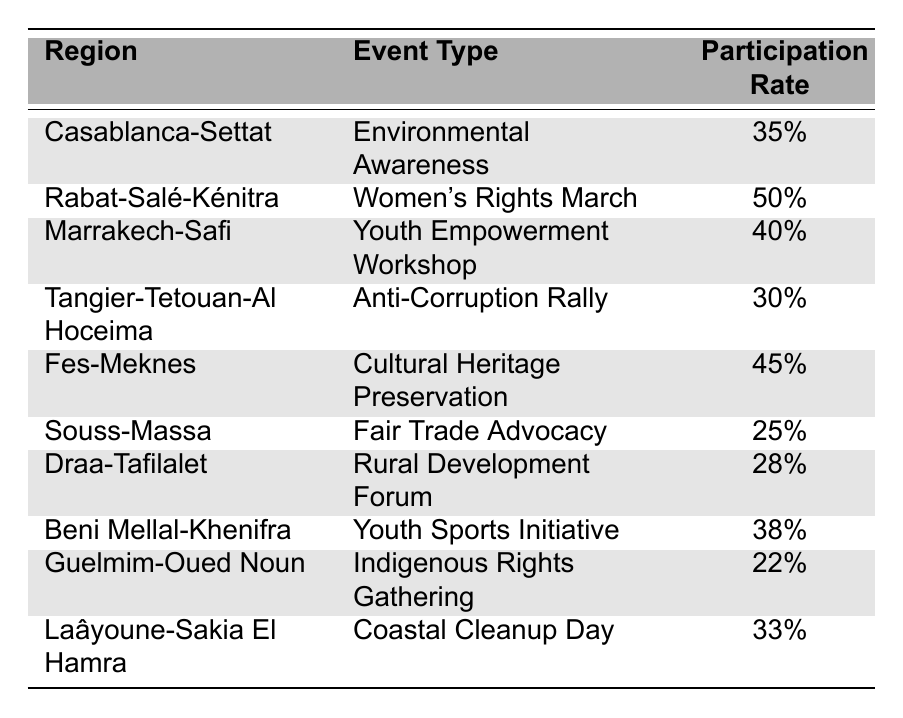What is the participation rate for the Women's Rights March in Rabat-Salé-Kénitra? The table indicates that the event type for Rabat-Salé-Kénitra is the Women's Rights March, which has a participation rate of 50%.
Answer: 50% Which region had the highest participation rate? By comparing the participation rates, Rabat-Salé-Kénitra has the highest at 50%.
Answer: Rabat-Salé-Kénitra What is the difference in participation rates between the Anti-Corruption Rally and the Youth Empowerment Workshop? The Anti-Corruption Rally has a participation rate of 30%, while the Youth Empowerment Workshop has a rate of 40%. The difference is 40% - 30% = 10%.
Answer: 10% Which regions had a participation rate below 30%? By reviewing the table, only Guelmim-Oued Noun with a rate of 22% and Souss-Massa with 25% fall below 30%.
Answer: Guelmim-Oued Noun and Souss-Massa What is the average participation rate for the events listed in the table? The total participation rates are 35% + 50% + 40% + 30% + 45% + 25% + 28% + 38% + 22% + 33% = 376%. There are 10 regions, so the average is 376% / 10 = 37.6%.
Answer: 37.6% Did the Coastal Cleanup Day in Laâyoune-Sakia El Hamra have a higher participation rate than the Fair Trade Advocacy in Souss-Massa? Coastal Cleanup Day has a participation rate of 33%, while Fair Trade Advocacy has a rate of 25%. Since 33% is greater than 25%, this statement is true.
Answer: Yes How many regions had participation rates of 35% or more? The regions with 35% or more are Casablanca-Settat (35%), Rabat-Salé-Kénitra (50%), Marrakech-Safi (40%), Fes-Meknes (45%), Beni Mellal-Khenifra (38%), and Laâyoune-Sakia El Hamra (33%). This gives a total of 6 regions.
Answer: 6 What is the total participation rate for the Youth Sports Initiative in Beni Mellal-Khenifra and the Fair Trade Advocacy in Souss-Massa? The Youth Sports Initiative has a participation rate of 38%, and the Fair Trade Advocacy has a rate of 25%. Adding these together gives 38% + 25% = 63%.
Answer: 63% Which event type had the lowest participation rate, and what was that rate? The event type with the lowest participation rate is the Indigenous Rights Gathering in Guelmim-Oued Noun, which has a rate of 22%.
Answer: Indigenous Rights Gathering, 22% Are there any events with a participation rate of exactly 30%? The table shows the Anti-Corruption Rally in Tangier-Tetouan-Al Hoceima has a participation rate of 30%, so yes, there is an event with that rate.
Answer: Yes 